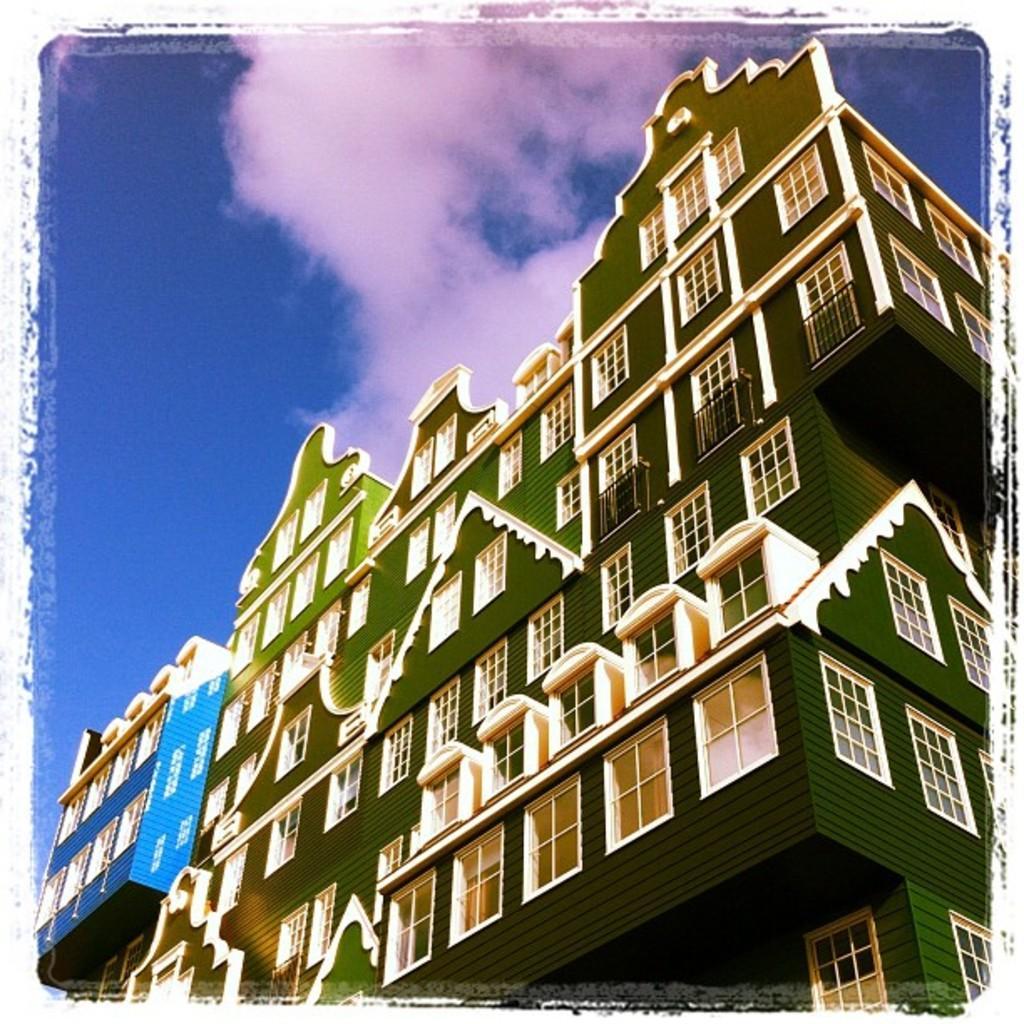Can you describe this image briefly? This is a building with the windows, this is sky. 